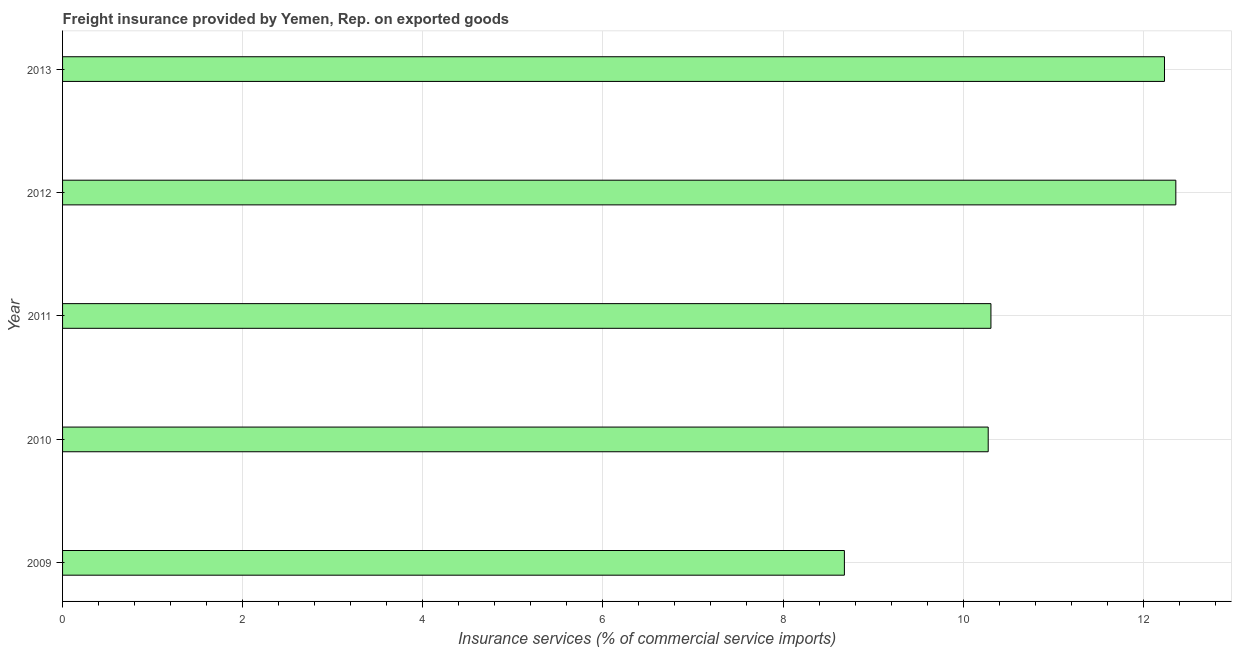Does the graph contain grids?
Provide a short and direct response. Yes. What is the title of the graph?
Offer a terse response. Freight insurance provided by Yemen, Rep. on exported goods . What is the label or title of the X-axis?
Your answer should be compact. Insurance services (% of commercial service imports). What is the label or title of the Y-axis?
Offer a very short reply. Year. What is the freight insurance in 2011?
Keep it short and to the point. 10.31. Across all years, what is the maximum freight insurance?
Your answer should be compact. 12.36. Across all years, what is the minimum freight insurance?
Your answer should be very brief. 8.68. In which year was the freight insurance maximum?
Your answer should be very brief. 2012. In which year was the freight insurance minimum?
Ensure brevity in your answer.  2009. What is the sum of the freight insurance?
Provide a succinct answer. 53.87. What is the difference between the freight insurance in 2009 and 2010?
Your answer should be compact. -1.6. What is the average freight insurance per year?
Provide a succinct answer. 10.77. What is the median freight insurance?
Your answer should be compact. 10.31. What is the ratio of the freight insurance in 2010 to that in 2012?
Your response must be concise. 0.83. Is the freight insurance in 2009 less than that in 2012?
Provide a short and direct response. Yes. What is the difference between the highest and the second highest freight insurance?
Provide a succinct answer. 0.13. What is the difference between the highest and the lowest freight insurance?
Ensure brevity in your answer.  3.68. In how many years, is the freight insurance greater than the average freight insurance taken over all years?
Give a very brief answer. 2. How many bars are there?
Your response must be concise. 5. How many years are there in the graph?
Offer a very short reply. 5. What is the Insurance services (% of commercial service imports) in 2009?
Your answer should be very brief. 8.68. What is the Insurance services (% of commercial service imports) in 2010?
Offer a very short reply. 10.28. What is the Insurance services (% of commercial service imports) of 2011?
Keep it short and to the point. 10.31. What is the Insurance services (% of commercial service imports) of 2012?
Your answer should be very brief. 12.36. What is the Insurance services (% of commercial service imports) of 2013?
Offer a very short reply. 12.24. What is the difference between the Insurance services (% of commercial service imports) in 2009 and 2010?
Your answer should be compact. -1.6. What is the difference between the Insurance services (% of commercial service imports) in 2009 and 2011?
Provide a succinct answer. -1.63. What is the difference between the Insurance services (% of commercial service imports) in 2009 and 2012?
Give a very brief answer. -3.68. What is the difference between the Insurance services (% of commercial service imports) in 2009 and 2013?
Give a very brief answer. -3.55. What is the difference between the Insurance services (% of commercial service imports) in 2010 and 2011?
Give a very brief answer. -0.03. What is the difference between the Insurance services (% of commercial service imports) in 2010 and 2012?
Provide a succinct answer. -2.08. What is the difference between the Insurance services (% of commercial service imports) in 2010 and 2013?
Ensure brevity in your answer.  -1.96. What is the difference between the Insurance services (% of commercial service imports) in 2011 and 2012?
Your response must be concise. -2.05. What is the difference between the Insurance services (% of commercial service imports) in 2011 and 2013?
Give a very brief answer. -1.93. What is the difference between the Insurance services (% of commercial service imports) in 2012 and 2013?
Give a very brief answer. 0.13. What is the ratio of the Insurance services (% of commercial service imports) in 2009 to that in 2010?
Make the answer very short. 0.84. What is the ratio of the Insurance services (% of commercial service imports) in 2009 to that in 2011?
Give a very brief answer. 0.84. What is the ratio of the Insurance services (% of commercial service imports) in 2009 to that in 2012?
Provide a succinct answer. 0.7. What is the ratio of the Insurance services (% of commercial service imports) in 2009 to that in 2013?
Your response must be concise. 0.71. What is the ratio of the Insurance services (% of commercial service imports) in 2010 to that in 2011?
Ensure brevity in your answer.  1. What is the ratio of the Insurance services (% of commercial service imports) in 2010 to that in 2012?
Your answer should be very brief. 0.83. What is the ratio of the Insurance services (% of commercial service imports) in 2010 to that in 2013?
Provide a short and direct response. 0.84. What is the ratio of the Insurance services (% of commercial service imports) in 2011 to that in 2012?
Provide a succinct answer. 0.83. What is the ratio of the Insurance services (% of commercial service imports) in 2011 to that in 2013?
Offer a terse response. 0.84. 